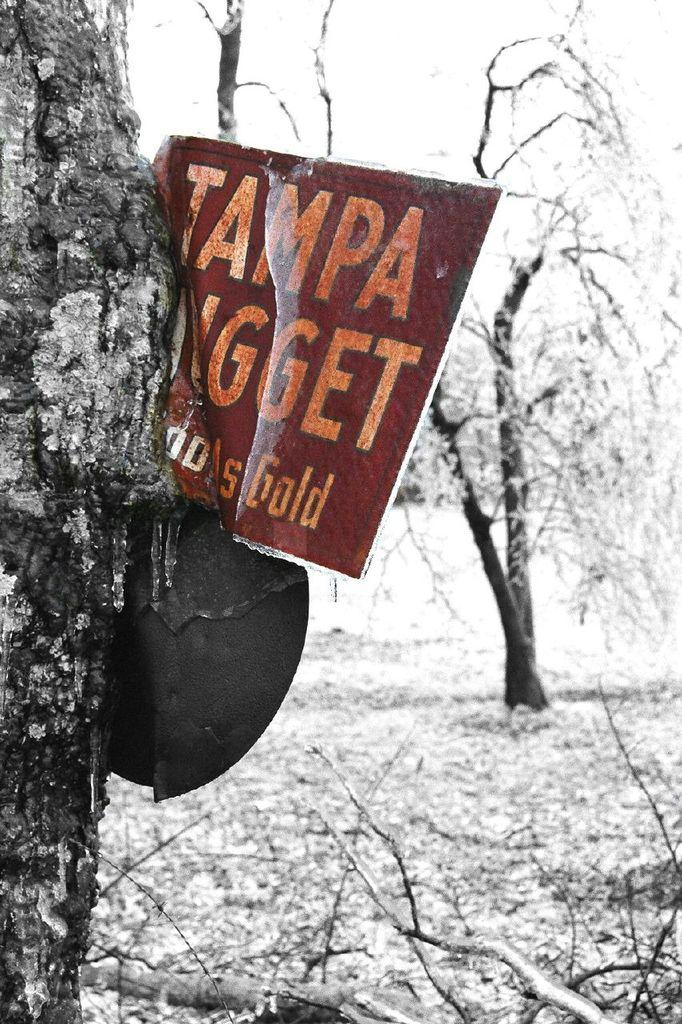What is on the board that is visible in the image? There are letters on the board in the image. What natural object is in the image? There is a tree trunk in the image. What type of vegetation is visible in the image? Trees are visible in the image. What part of the trees is present in the image? Branches are present in the image. Can you hear the bell ringing in the image? There is no bell present in the image, so it cannot be heard. Is there a house visible in the image? There is no house mentioned in the provided facts, so we cannot determine if one is present in the image. 